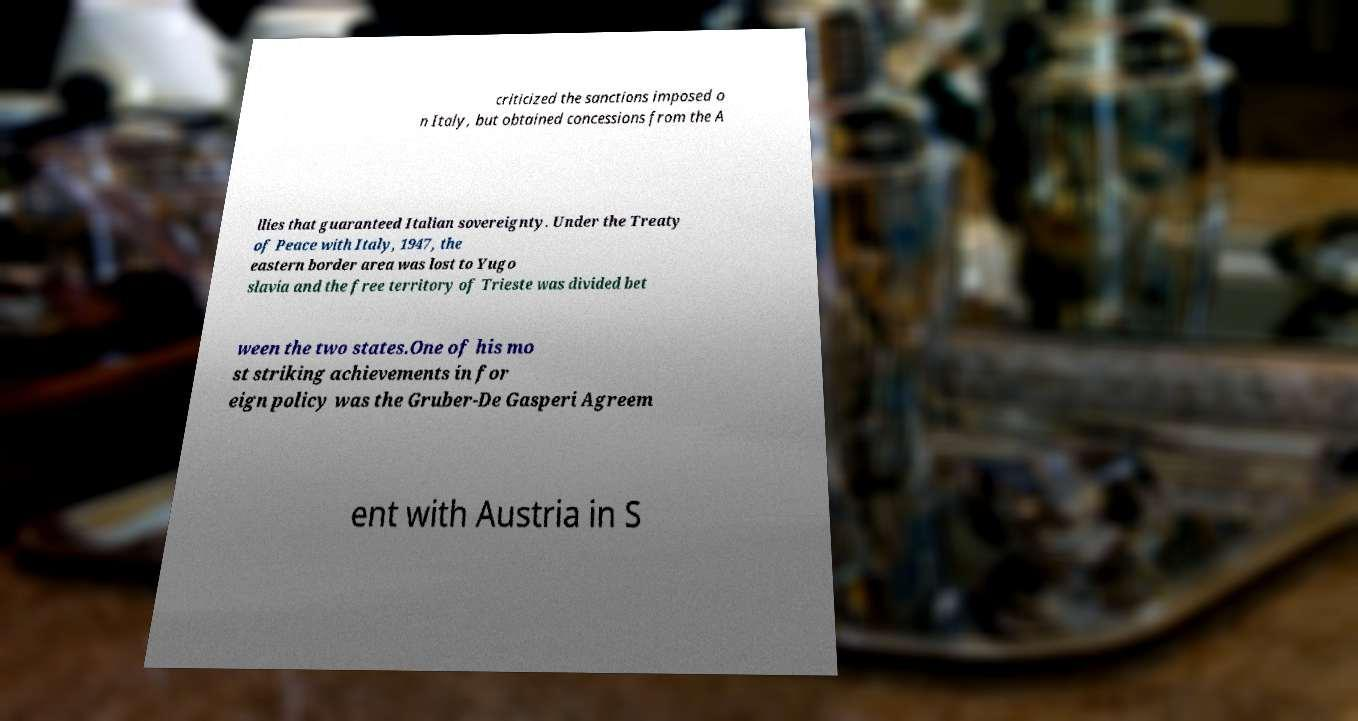Please read and relay the text visible in this image. What does it say? criticized the sanctions imposed o n Italy, but obtained concessions from the A llies that guaranteed Italian sovereignty. Under the Treaty of Peace with Italy, 1947, the eastern border area was lost to Yugo slavia and the free territory of Trieste was divided bet ween the two states.One of his mo st striking achievements in for eign policy was the Gruber-De Gasperi Agreem ent with Austria in S 